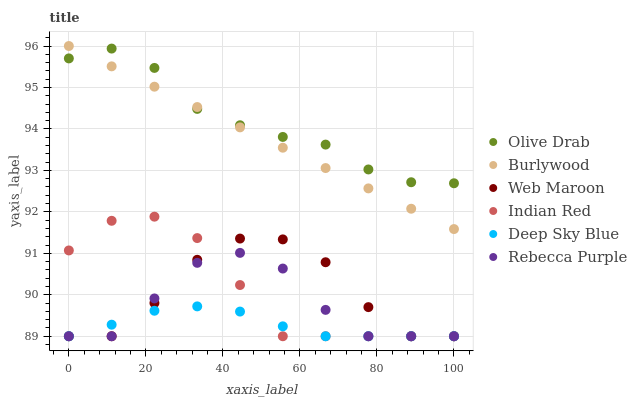Does Deep Sky Blue have the minimum area under the curve?
Answer yes or no. Yes. Does Olive Drab have the maximum area under the curve?
Answer yes or no. Yes. Does Burlywood have the minimum area under the curve?
Answer yes or no. No. Does Burlywood have the maximum area under the curve?
Answer yes or no. No. Is Burlywood the smoothest?
Answer yes or no. Yes. Is Web Maroon the roughest?
Answer yes or no. Yes. Is Web Maroon the smoothest?
Answer yes or no. No. Is Burlywood the roughest?
Answer yes or no. No. Does Indian Red have the lowest value?
Answer yes or no. Yes. Does Burlywood have the lowest value?
Answer yes or no. No. Does Burlywood have the highest value?
Answer yes or no. Yes. Does Web Maroon have the highest value?
Answer yes or no. No. Is Deep Sky Blue less than Burlywood?
Answer yes or no. Yes. Is Burlywood greater than Deep Sky Blue?
Answer yes or no. Yes. Does Indian Red intersect Rebecca Purple?
Answer yes or no. Yes. Is Indian Red less than Rebecca Purple?
Answer yes or no. No. Is Indian Red greater than Rebecca Purple?
Answer yes or no. No. Does Deep Sky Blue intersect Burlywood?
Answer yes or no. No. 